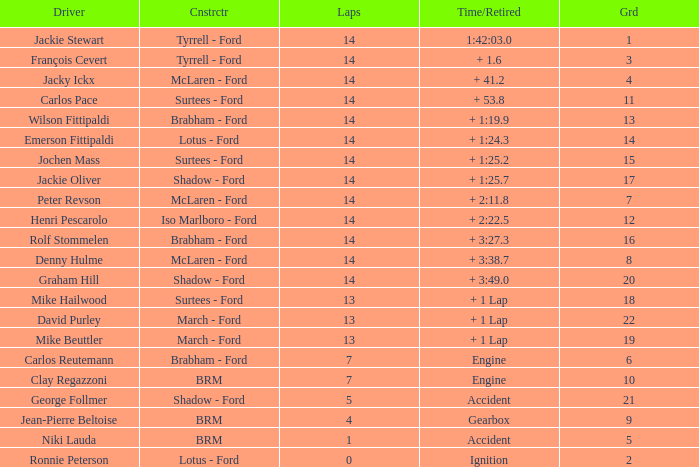What is the low lap total for henri pescarolo with a grad larger than 6? 14.0. 